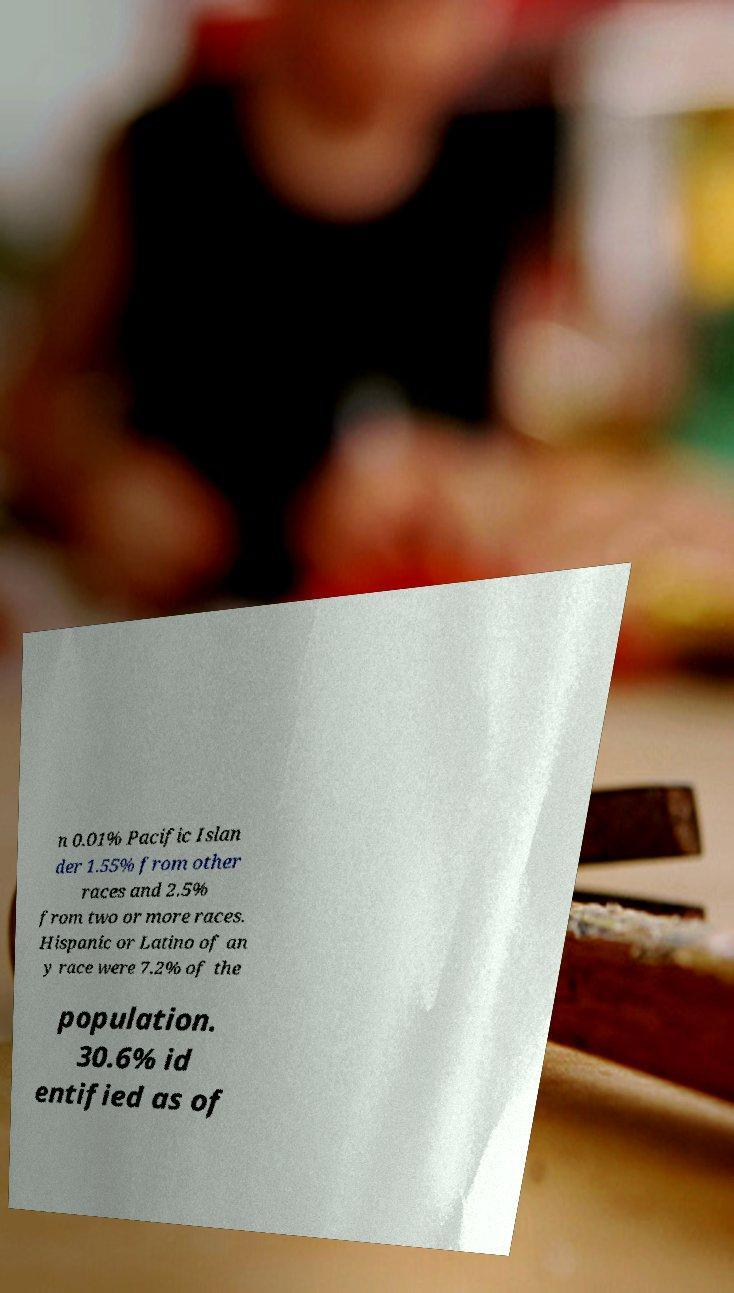Could you extract and type out the text from this image? n 0.01% Pacific Islan der 1.55% from other races and 2.5% from two or more races. Hispanic or Latino of an y race were 7.2% of the population. 30.6% id entified as of 